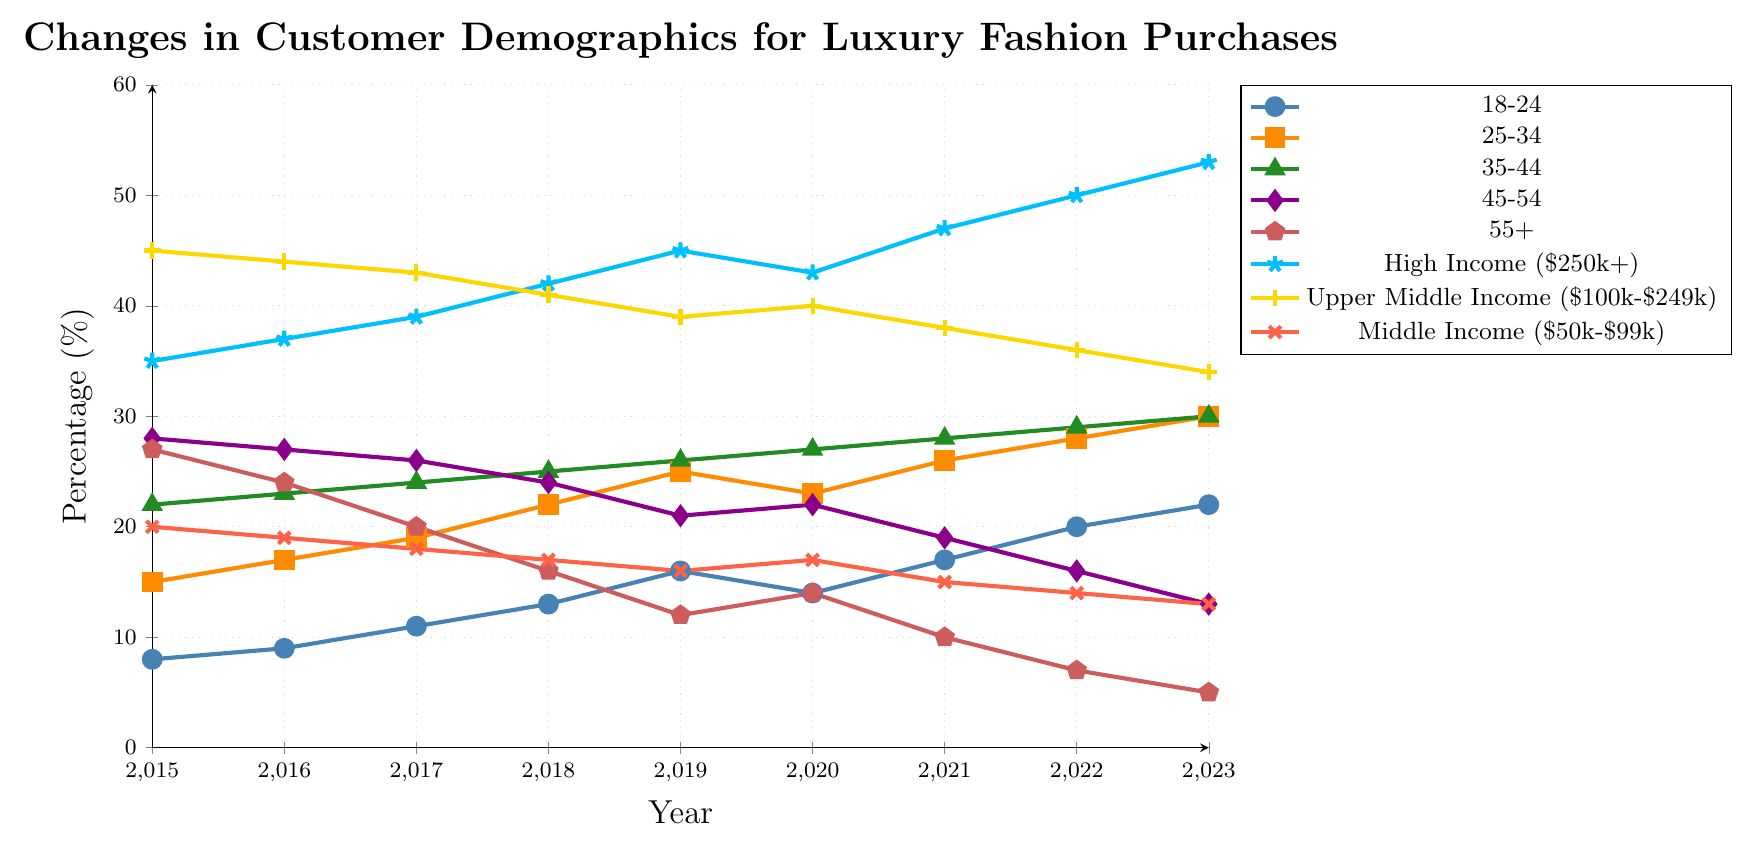Which age group saw the most significant increase in percentages from 2015 to 2023? Look at the start and end percentages for each age group. The 18-24 group increased from 8% to 22%, the largest change among all age groups.
Answer: 18-24 By how much did the percentage of the 45-54 age group decrease from 2015 to 2023? In 2015, the 45-54 age group was at 28%, and by 2023 it decreased to 13%. The difference is 28 - 13 = 15%.
Answer: 15% Which income level group consistently had the highest percentage over the years? Compare the percentages of all income level groups year by year. High Income ($250k+) was always higher than other groups, starting at 35% in 2015 and reaching 53% in 2023.
Answer: High Income ($250k+) What is the trend for the Upper Middle Income ($100k-$249k) group from 2015 to 2023? The percentages for this group decreased slowly from 45% in 2015 to 34% in 2023, indicating a downward trend.
Answer: Decreasing In 2023, what is the combined percentage of the 35-44 and 45-54 age groups? Add the 2023 percentages for both groups: 30% (35-44) + 13% (45-54) = 43%.
Answer: 43% Which group has the least percentage change over the years? Compare the start and end percentages for minimal changes. For Middle Income ($50k-$99k), it went from 20% in 2015 to 13% in 2023, the change being 7%, smaller than most other groups.
Answer: Middle Income ($50k-$99k) Which year had the highest percentage for the 25-34 age group? Look at the plot for the 25-34 age group and identify the year with the highest peak, which is 2023 with 30%.
Answer: 2023 From 2015 to 2023, how does the trend in the 55+ age group compare to the High Income group? The 55+ age group shows a significant decrease from 27% to 5%, while the High Income group shows a significant increase from 35% to 53%. The trends are in opposite directions, one decreasing and the other increasing.
Answer: Opposite trends Are there any age groups where the percentage dropped below 10% by 2023? Check each age group's percentage in 2023. The 55+ age group dropped to 5% by 2023.
Answer: Yes, 55+ What has been the general trend for the middle-income group ($50k-$99k) from 2015 to 2023? The middle-income group's percentage decreased steadily from 20% in 2015 to 13% in 2023.
Answer: Decreasing 